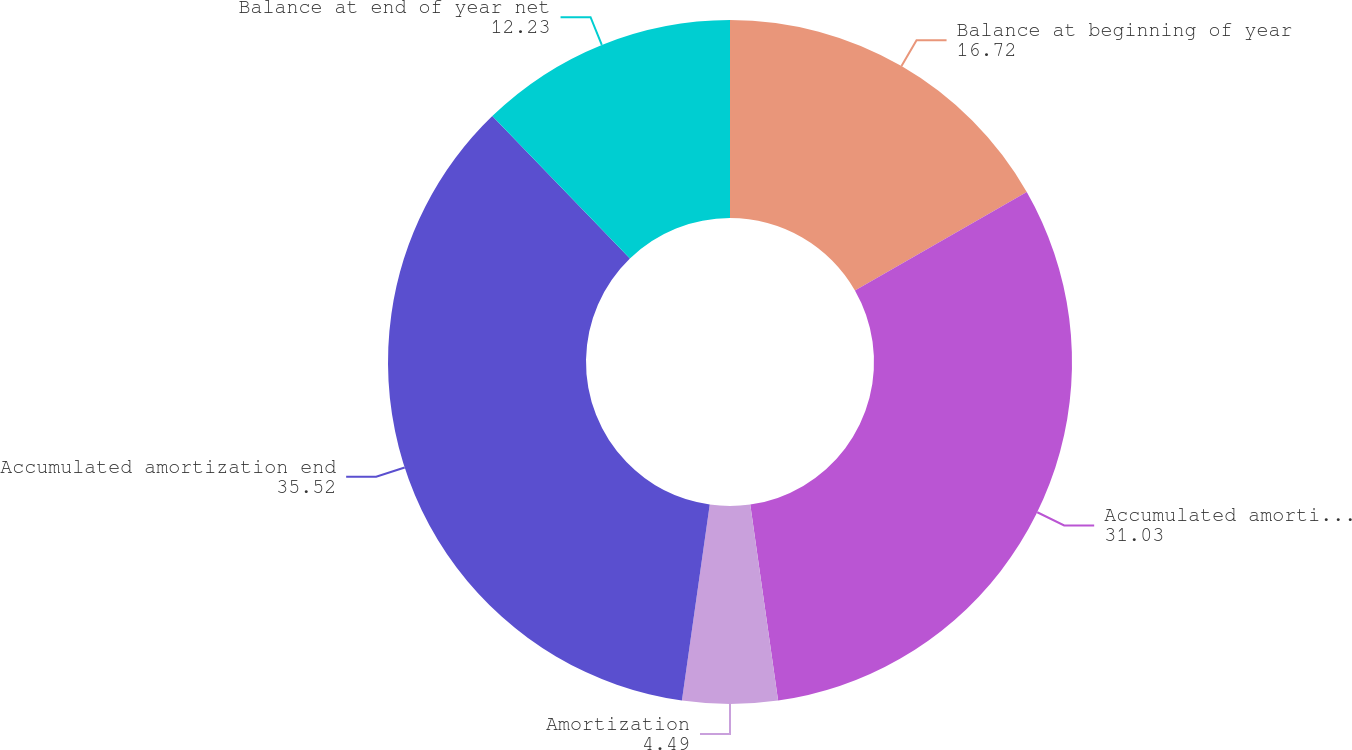Convert chart to OTSL. <chart><loc_0><loc_0><loc_500><loc_500><pie_chart><fcel>Balance at beginning of year<fcel>Accumulated amortization<fcel>Amortization<fcel>Accumulated amortization end<fcel>Balance at end of year net<nl><fcel>16.72%<fcel>31.03%<fcel>4.49%<fcel>35.52%<fcel>12.23%<nl></chart> 